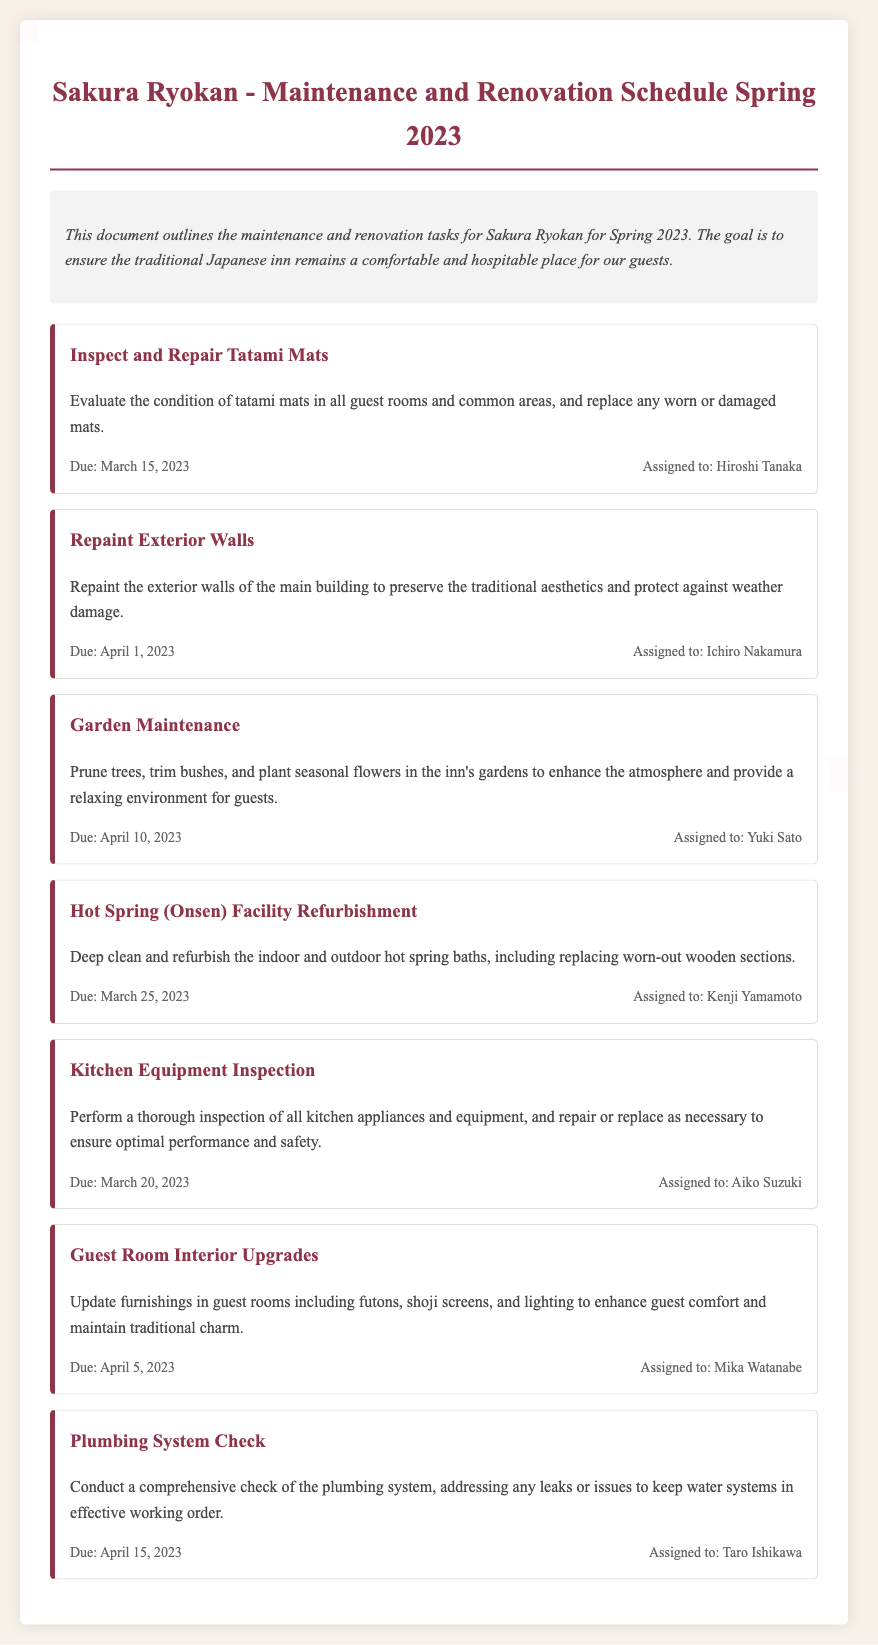What is the title of the document? The title is mentioned at the beginning of the document in a prominent heading format.
Answer: Sakura Ryokan - Maintenance and Renovation Schedule Spring 2023 Who is responsible for inspecting and repairing the tatami mats? Each task includes information about who is assigned to complete it, in this case, it's Hiroshi Tanaka.
Answer: Hiroshi Tanaka What is the due date for the plumbing system check? The document lists completion dates for each task, and the plumbing system check is due on April 15, 2023.
Answer: April 15, 2023 How many tasks are listed in the document? By counting the individual task sections in the document, the total number can be determined.
Answer: Seven What task is due on April 1, 2023? Each task is paired with its due date; the task due on this date is repainting the exterior walls.
Answer: Repaint Exterior Walls What task involves enhancing guest comfort? The document specifies tasks aimed at improving the guest experience; this one relates to guest room interior upgrades.
Answer: Guest Room Interior Upgrades Which assigned personnel is responsible for garden maintenance? The task assignment details include the name of the person in charge of garden maintenance, which is Yuki Sato.
Answer: Yuki Sato What is the primary goal of the maintenance schedule? The document outlines the overall objective of the tasks, which is to ensure the inn remains a comfortable place for guests.
Answer: Ensure comfort 